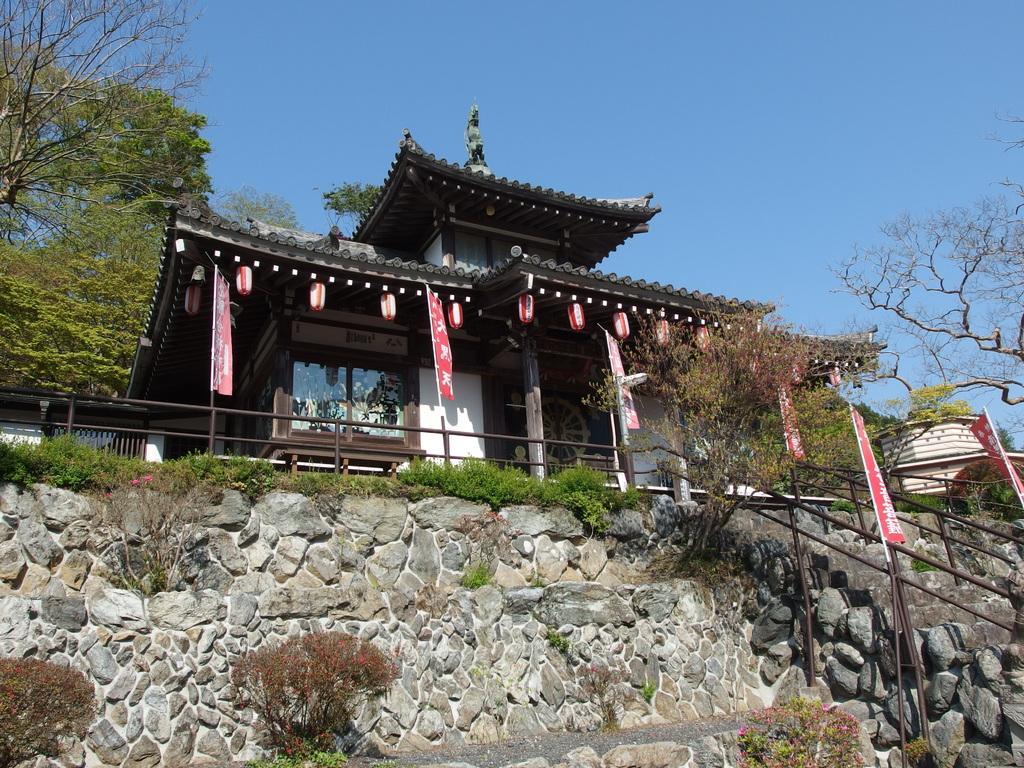How would you summarize this image in a sentence or two? In this image there are buildings in which there are lights and posters hanging to the roof of one of the buildings, there are few trees, stairs, a fence, plants, a stone wall and the sky. 